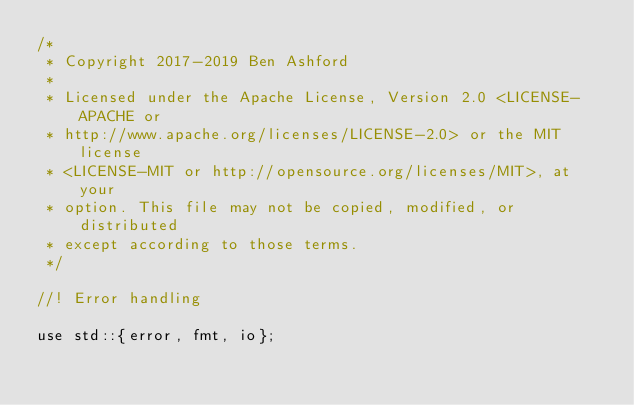Convert code to text. <code><loc_0><loc_0><loc_500><loc_500><_Rust_>/*
 * Copyright 2017-2019 Ben Ashford
 *
 * Licensed under the Apache License, Version 2.0 <LICENSE-APACHE or
 * http://www.apache.org/licenses/LICENSE-2.0> or the MIT license
 * <LICENSE-MIT or http://opensource.org/licenses/MIT>, at your
 * option. This file may not be copied, modified, or distributed
 * except according to those terms.
 */

//! Error handling

use std::{error, fmt, io};
</code> 